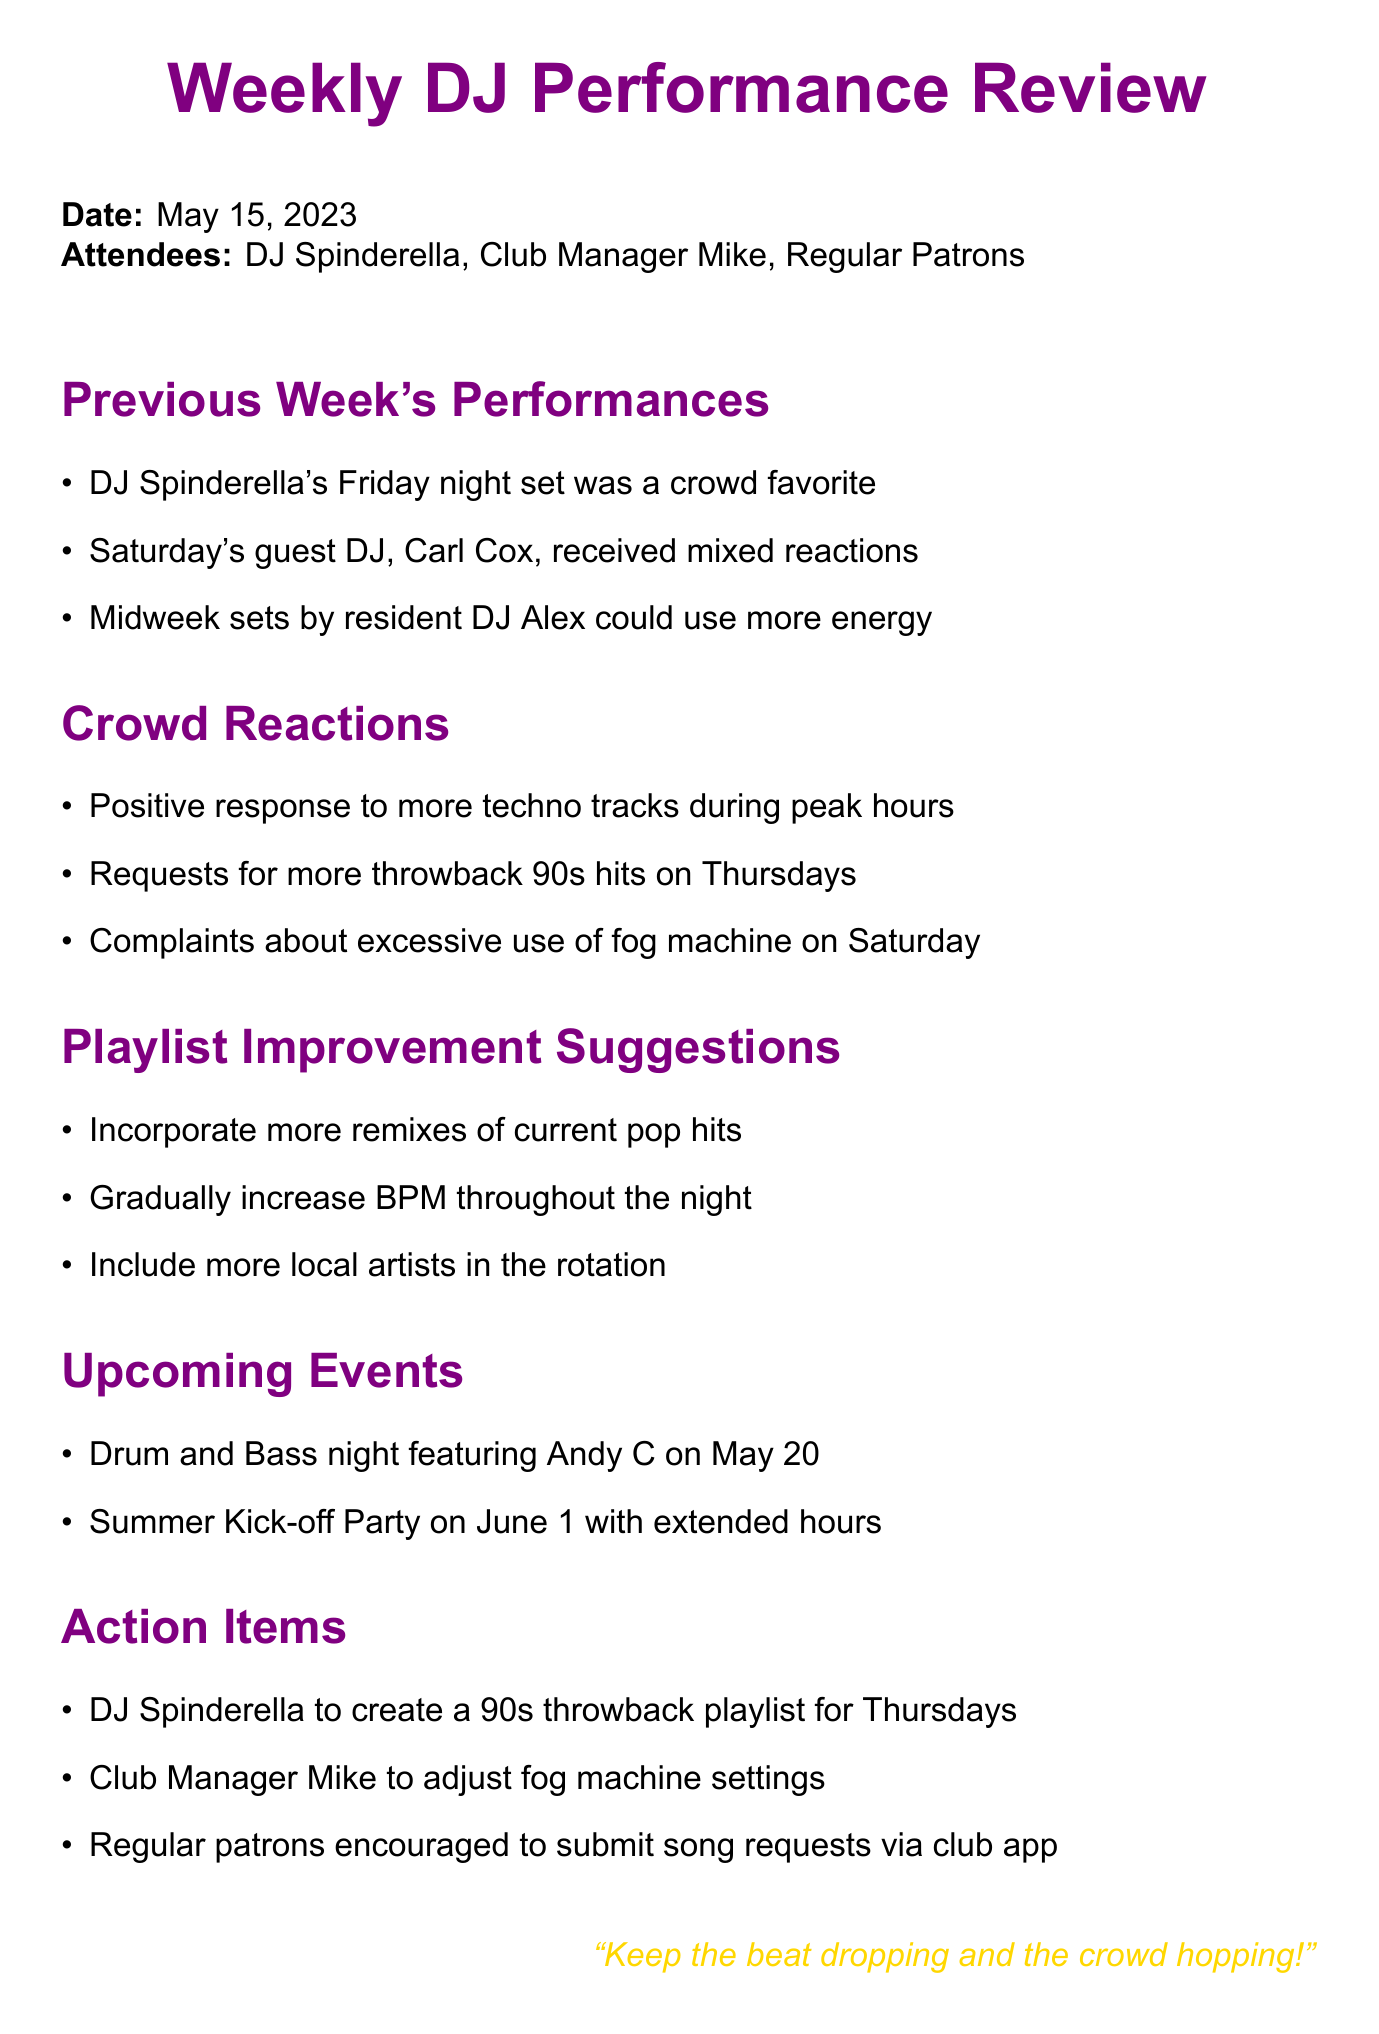What is the date of the meeting? The date of the meeting is explicitly stated at the beginning of the document.
Answer: May 15, 2023 Who was the guest DJ on Saturday? The document mentions the guest DJ on Saturday when discussing crowd reactions.
Answer: Carl Cox Which DJ's set was a crowd favorite? The document highlights DJ Spinderella's performance as a crowd favorite in the previous week's performances section.
Answer: DJ Spinderella What genre received a positive response during peak hours? The document specifies the crowd's favorable reaction to a particular genre during peak hours.
Answer: Techno tracks What playlist item did DJ Spinderella commit to creating? The action items section of the document states the specific commitment made by DJ Spinderella.
Answer: 90s throwback playlist for Thursdays How should the BPM change throughout the night according to suggestions? The document suggests a specific way to adjust the BPM in relation to the overall performance timeline.
Answer: Gradually increase What is one complaint mentioned from the crowd? The document notes at least one specific complaint regarding the atmosphere during one of the performances.
Answer: Excessive use of fog machine What is the upcoming event featuring Andy C? The upcoming events section specifies a particular event highlighting a guest DJ.
Answer: Drum and Bass night How are regular patrons encouraged to submit requests? The document articulates a specific method for patrons to communicate their song requests.
Answer: Via club app 